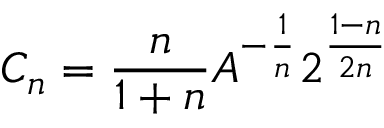<formula> <loc_0><loc_0><loc_500><loc_500>C _ { n } = \frac { n } { 1 + n } A ^ { - \frac { 1 } { n } } 2 ^ { \frac { 1 - n } { 2 n } }</formula> 